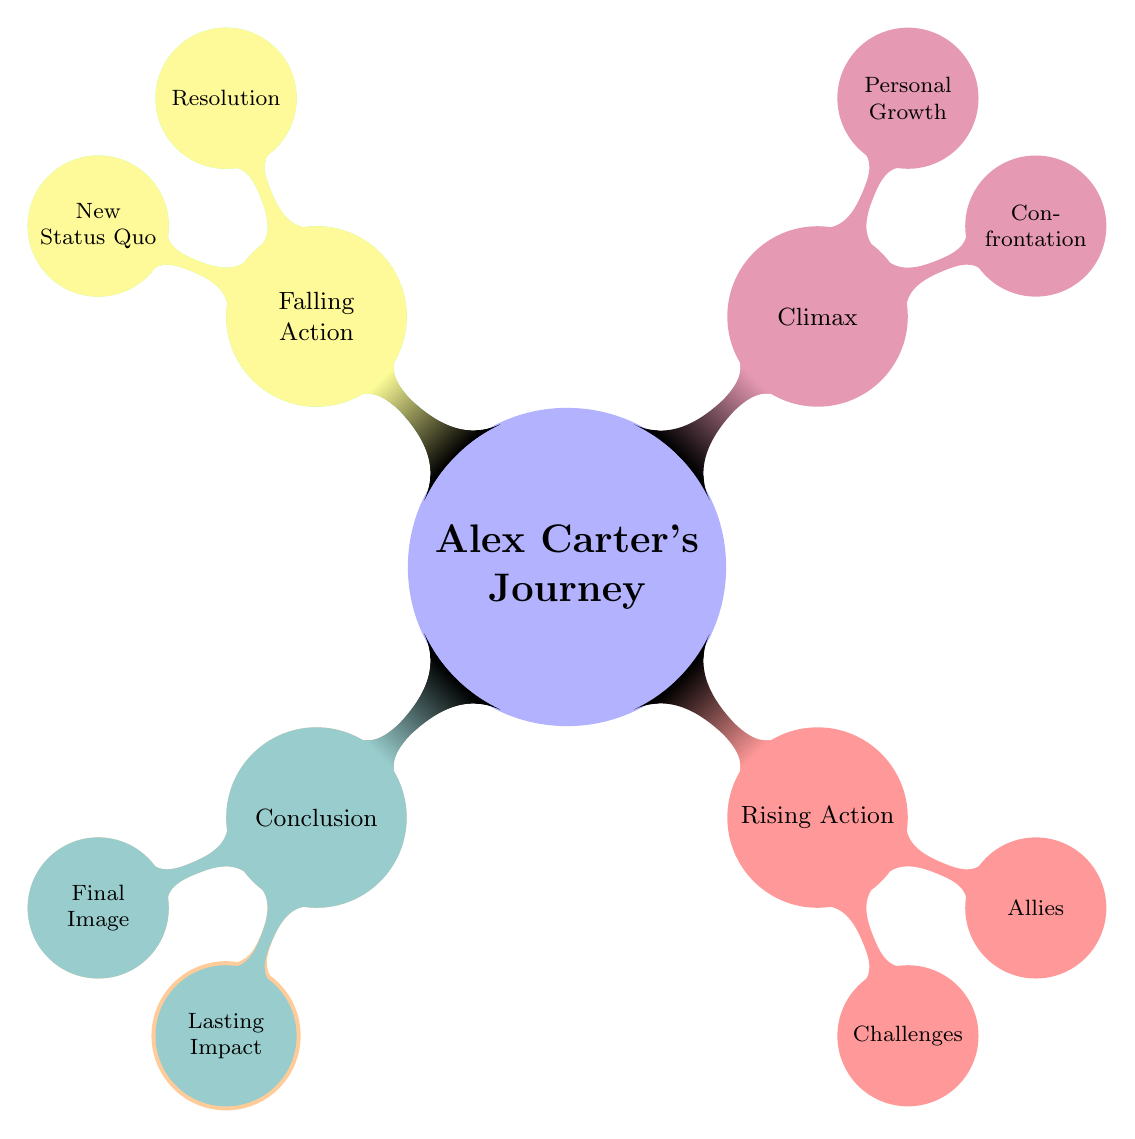What is the age of the protagonist? The diagram states that Alex Carter is 28 years old under the Background section of Introduction.
Answer: 28 Who are the three allies named in the Rising Action? In the Rising Action section, the diagram lists the allies as Jordan, Emily, and Mr. Thompson.
Answer: Jordan, Emily, Mr. Thompson What event triggers the protagonist's journey? The Inciting Incident node in the diagram mentions that the event triggering the journey is the protagonist stumbling upon a controversial, unpublished manuscript.
Answer: Stumbles upon a controversial, unpublished manuscript What internal conflicts does the protagonist face? The Rising Action node outlines internal conflicts which include self-doubt and trust issues, found in the Challenges section.
Answer: Self-Doubt, Trust Issues Where does the climax confrontation take place? The Climax section specifies that the confrontation with the vindictive publisher occurs at Grand Central Terminal.
Answer: Grand Central Terminal What is the new status quo for Alex at the end of the story? The Falling Action node explains that the new status quo reflects Alex gaining respect and a new sense of purpose after the resolution of the plot.
Answer: Gains respect and a new sense of purpose What significant realization does Alex achieve during the climax? In the Climax section, it is indicated that during the climax, Alex learns the importance of truth and integrity in storytelling, which represents personal growth.
Answer: Importance of truth and integrity How does Alex's personal situation change by the conclusion? The Conclusion node describes that Alex feels empowered to continue uncovering the truth and telling meaningful stories, indicating a positive change in personal situation.
Answer: Empowered to continue uncovering the truth Which emotional state does Alex experience while writing at the café? The Final Image under the Conclusion specifies that Alex's mood while writing at a cozy café is hopeful and determined.
Answer: Hopeful and Determined 